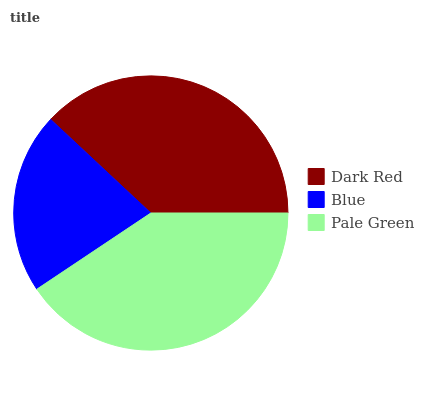Is Blue the minimum?
Answer yes or no. Yes. Is Pale Green the maximum?
Answer yes or no. Yes. Is Pale Green the minimum?
Answer yes or no. No. Is Blue the maximum?
Answer yes or no. No. Is Pale Green greater than Blue?
Answer yes or no. Yes. Is Blue less than Pale Green?
Answer yes or no. Yes. Is Blue greater than Pale Green?
Answer yes or no. No. Is Pale Green less than Blue?
Answer yes or no. No. Is Dark Red the high median?
Answer yes or no. Yes. Is Dark Red the low median?
Answer yes or no. Yes. Is Blue the high median?
Answer yes or no. No. Is Blue the low median?
Answer yes or no. No. 